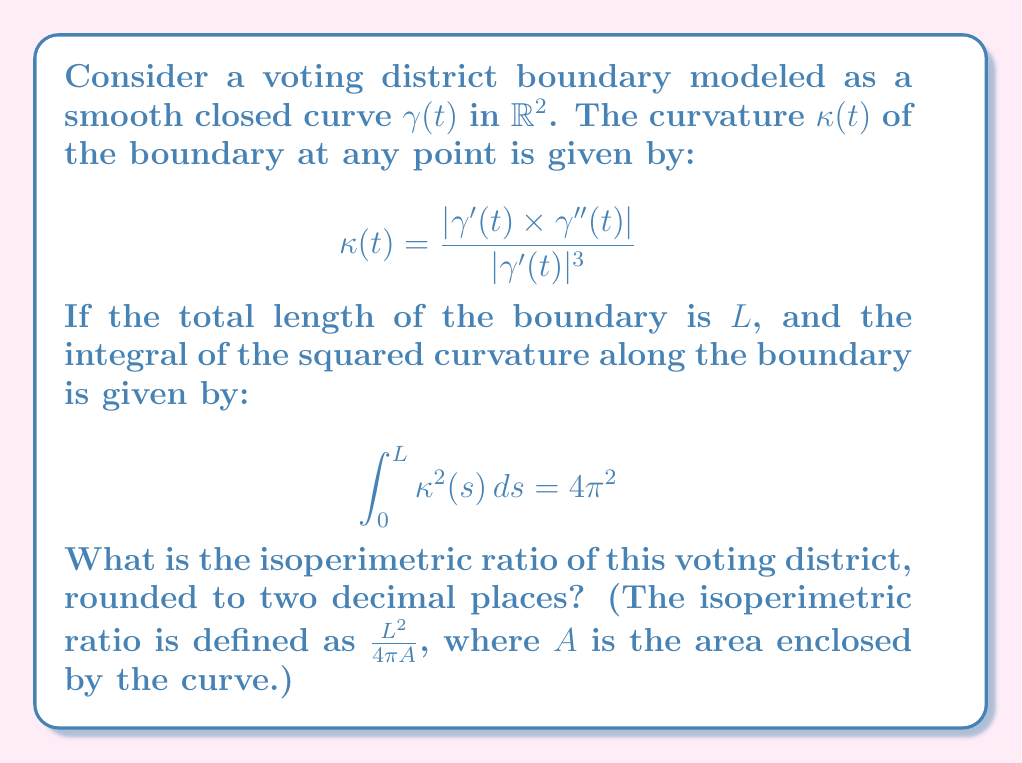Solve this math problem. To solve this problem, we'll use the following steps:

1) First, recall the isoperimetric inequality, which states that for any closed curve of length $L$ enclosing an area $A$:

   $$L^2 \geq 4\pi A$$

   with equality holding only for a circle.

2) The isoperimetric ratio is defined as $\frac{L^2}{4\pi A}$, which is always $\geq 1$, with 1 being achieved only by a circle.

3) Now, we can use a theorem from differential geometry known as the Fenchel-Borsuk theorem. This theorem states that for any closed curve in $\mathbb{R}^2$:

   $$\int_0^L \kappa(s) ds = 2\pi$$

4) We're given that $\int_0^L \kappa^2(s) ds = 4\pi^2$. Let's apply the Cauchy-Schwarz inequality:

   $$\left(\int_0^L \kappa(s) ds\right)^2 \leq L \int_0^L \kappa^2(s) ds$$

5) Substituting the values we know:

   $$(2\pi)^2 \leq L(4\pi^2)$$

6) Simplifying:

   $$L \geq \frac{4\pi^2}{4\pi^2} = 1$$

7) This means the length of the curve is exactly 1.

8) Now, let's consider the isoperimetric inequality:

   $$1^2 \geq 4\pi A$$

   $$A \leq \frac{1}{4\pi}$$

9) The isoperimetric ratio is:

   $$\frac{L^2}{4\pi A} = \frac{1^2}{4\pi(\frac{1}{4\pi})} = 1$$

10) This ratio of 1 is achieved only by a circle, which has constant curvature.

Therefore, the voting district boundary must be a circle with radius $\frac{1}{2\pi}$ and length 1.
Answer: 1.00 